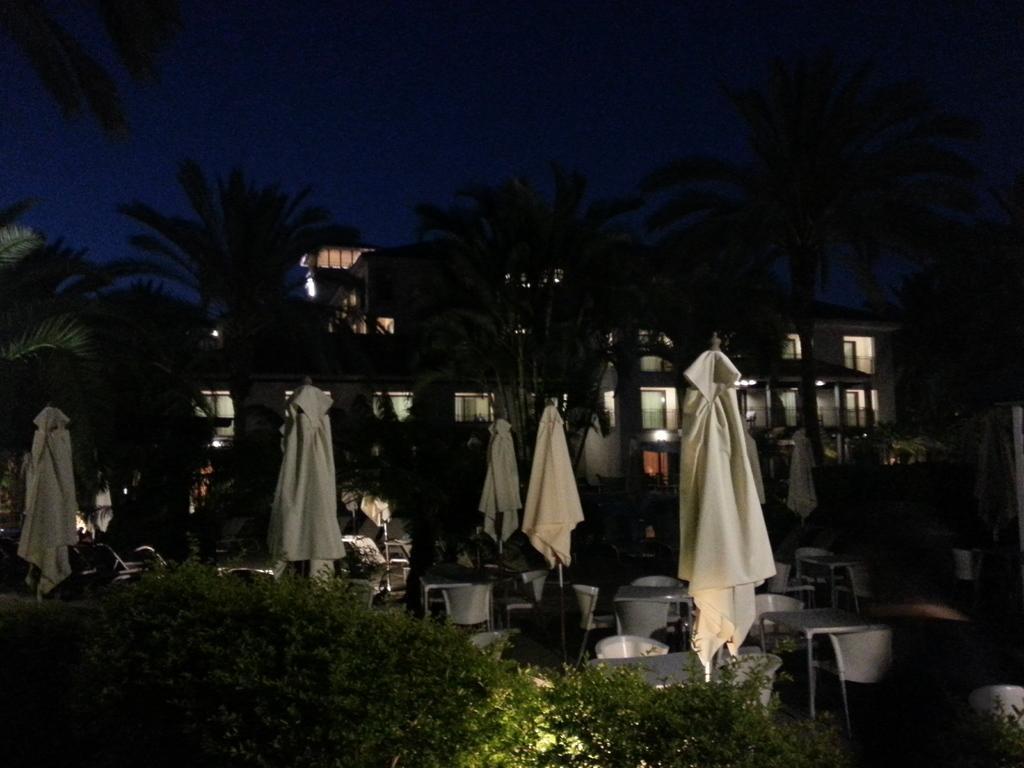Describe this image in one or two sentences. There are plants. In the back there are folded umbrellas, tables, chairs, buildings with lights, trees and sky. 